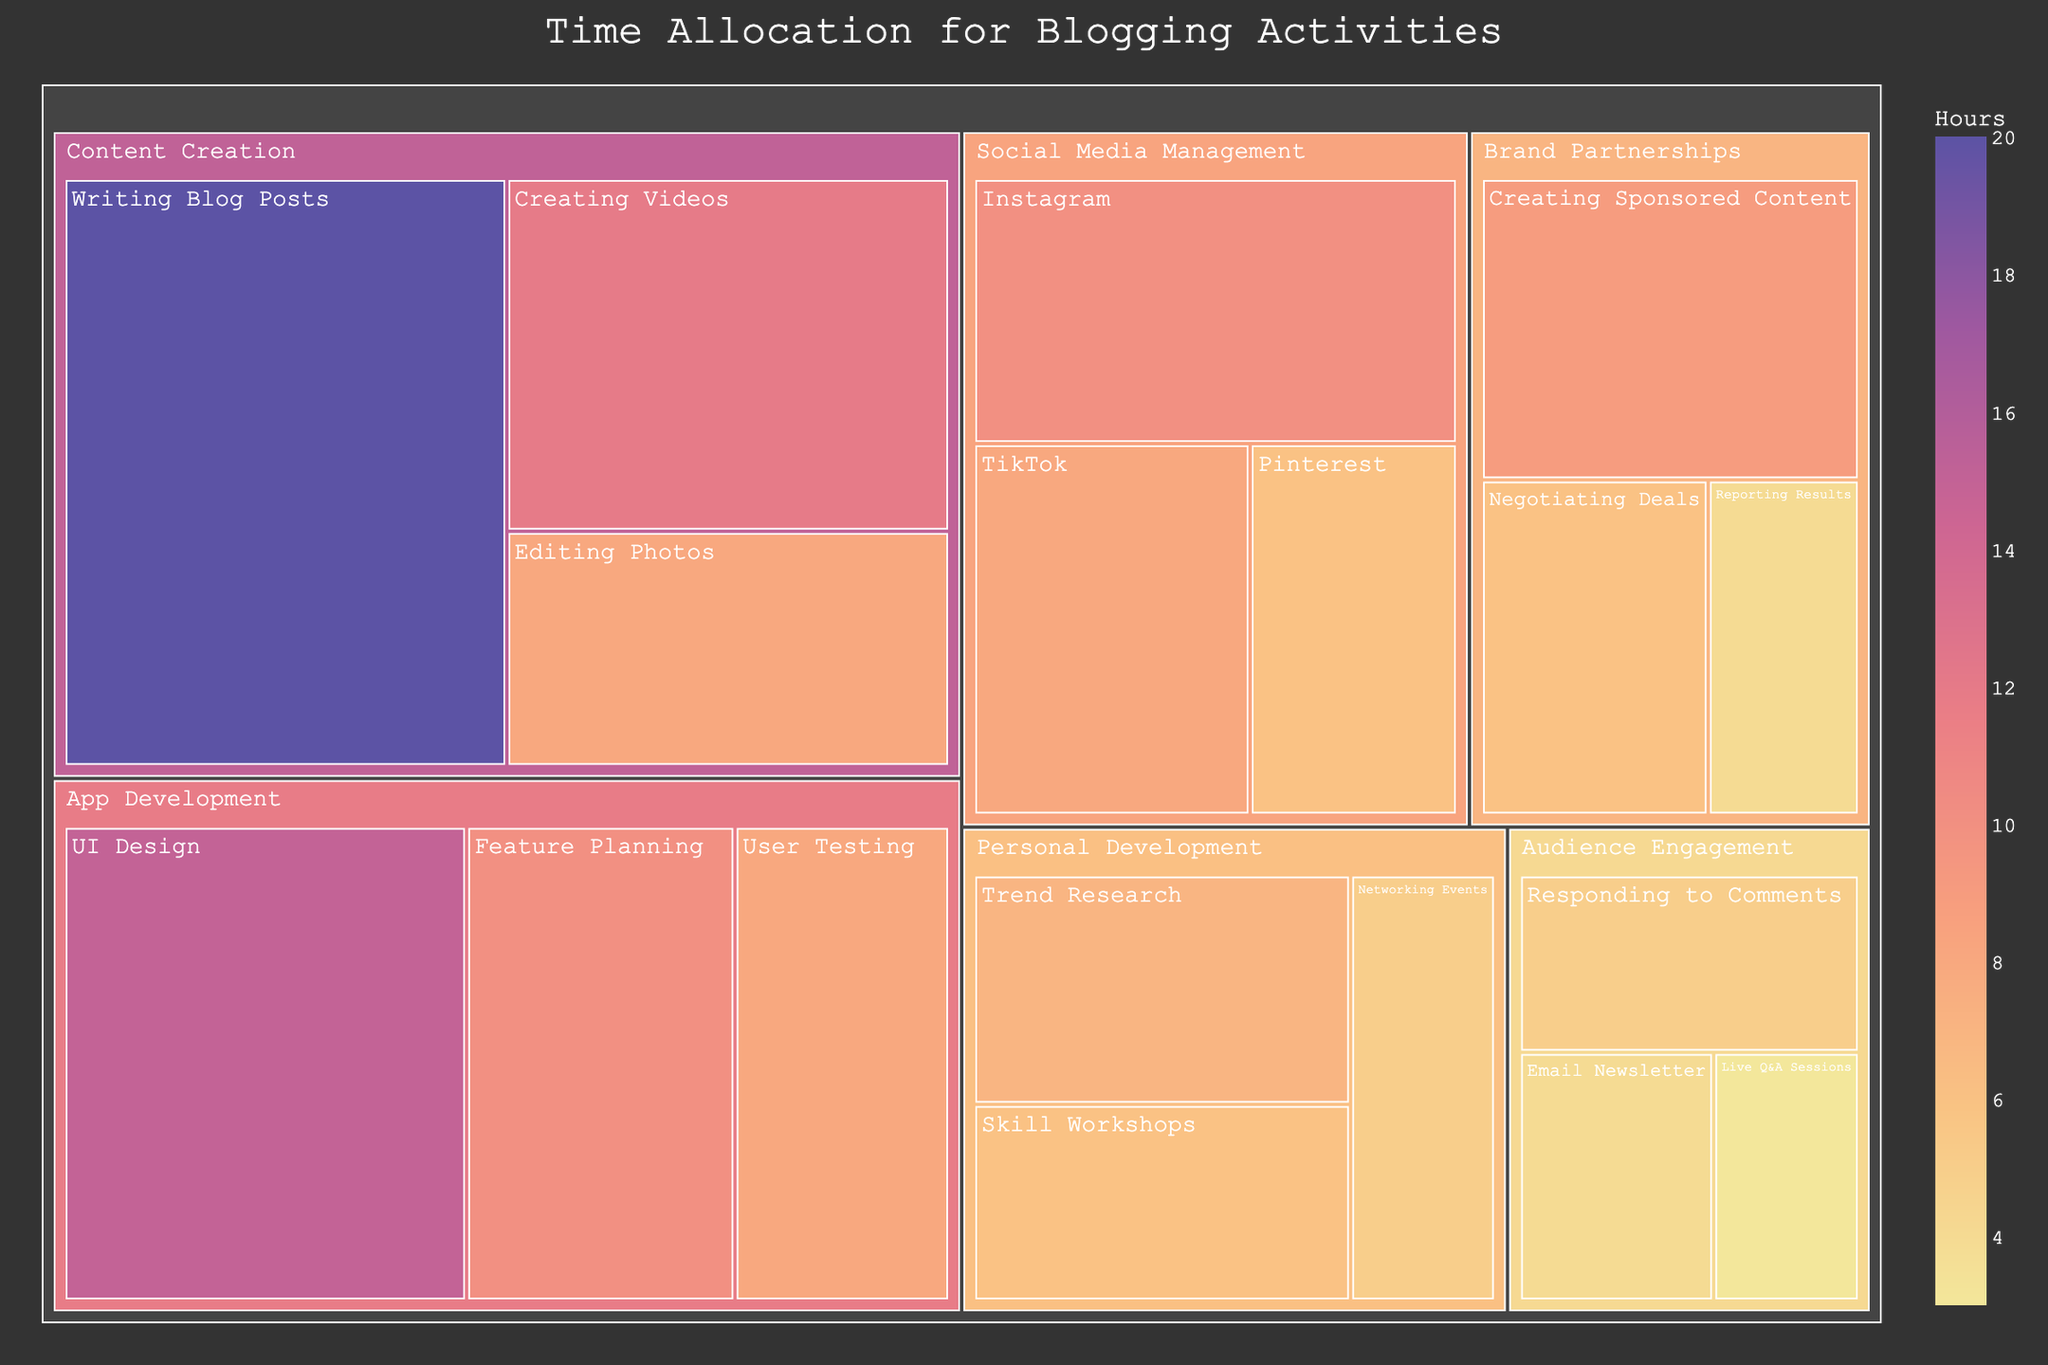Which category has the highest total hours allocated? By observing the Treemap, the category with the largest section will have the highest total hours. The "Content Creation" category occupies the most substantial area.
Answer: Content Creation What is the total time spent on App Development activities? Identify the subcategories under "App Development" in the Treemap and sum their hours: UI Design (15), Feature Planning (10), and User Testing (8). 15 + 10 + 8 = 33 hours
Answer: 33 hours How much more time is spent on Content Creation compared to Social Media Management? Find the total hours for both categories: "Content Creation" is Writing Blog Posts (20) + Editing Photos (8) + Creating Videos (12) = 40 hours. "Social Media Management" is Instagram (10) + Pinterest (6) + TikTok (8) = 24 hours. The difference is 40 - 24 = 16 hours
Answer: 16 hours Which subcategory within Brand Partnerships has the least hours allocated? Within "Brand Partnerships," compare "Negotiating Deals" (6), "Creating Sponsored Content" (9), and "Reporting Results" (4). The subcategory "Reporting Results" has the smallest value.
Answer: Reporting Results What is the percentage of time spent on Personal Development? Sum the hours of all subcategories under "Personal Development" (Trend Research 7, Networking Events 5, Skill Workshops 6) to get 18 hours. The total time across all categories is 140 hours. The percentage is (18/140)*100 ≈ 12.86%.
Answer: 12.86% Which subcategory within Content Creation uses the most hours? "Content Creation" has three subcategories: Writing Blog Posts (20), Editing Photos (8), and Creating Videos (12). Writing Blog Posts has the highest hours.
Answer: Writing Blog Posts How does the time spent on Skill Workshops compare with Responding to Comments? Look for "Skill Workshops" (6) in Personal Development and "Responding to Comments" (5) in Audience Engagement. Skill Workshops (6) has 1 more hour than Responding to Comments (5).
Answer: Skill Workshops has 1 more hour What are the top three subcategories with the highest hours? Identify the subcategories with the highest hours in descending order: Writing Blog Posts (20), UI Design (15), and Creating Videos (12).
Answer: Writing Blog Posts, UI Design, Creating Videos What is the total time spent across all categories on Brand Partnerships and Personal Development combined? Sum the hours for subcategories under "Brand Partnerships" (6 + 9 + 4 = 19) and "Personal Development" (7 + 5 + 6 = 18). The total is 19 + 18 = 37 hours.
Answer: 37 hours 